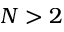<formula> <loc_0><loc_0><loc_500><loc_500>N > 2</formula> 